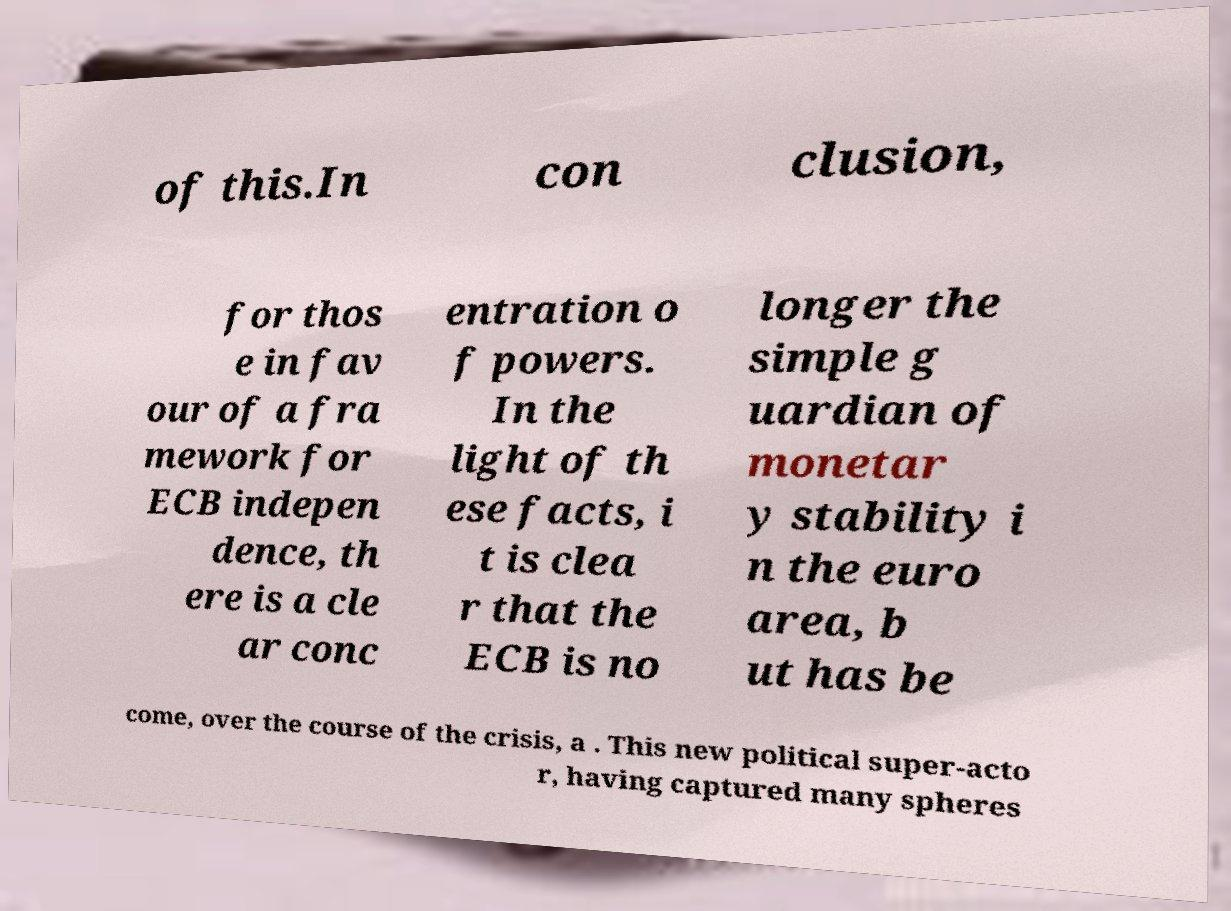There's text embedded in this image that I need extracted. Can you transcribe it verbatim? of this.In con clusion, for thos e in fav our of a fra mework for ECB indepen dence, th ere is a cle ar conc entration o f powers. In the light of th ese facts, i t is clea r that the ECB is no longer the simple g uardian of monetar y stability i n the euro area, b ut has be come, over the course of the crisis, a . This new political super-acto r, having captured many spheres 